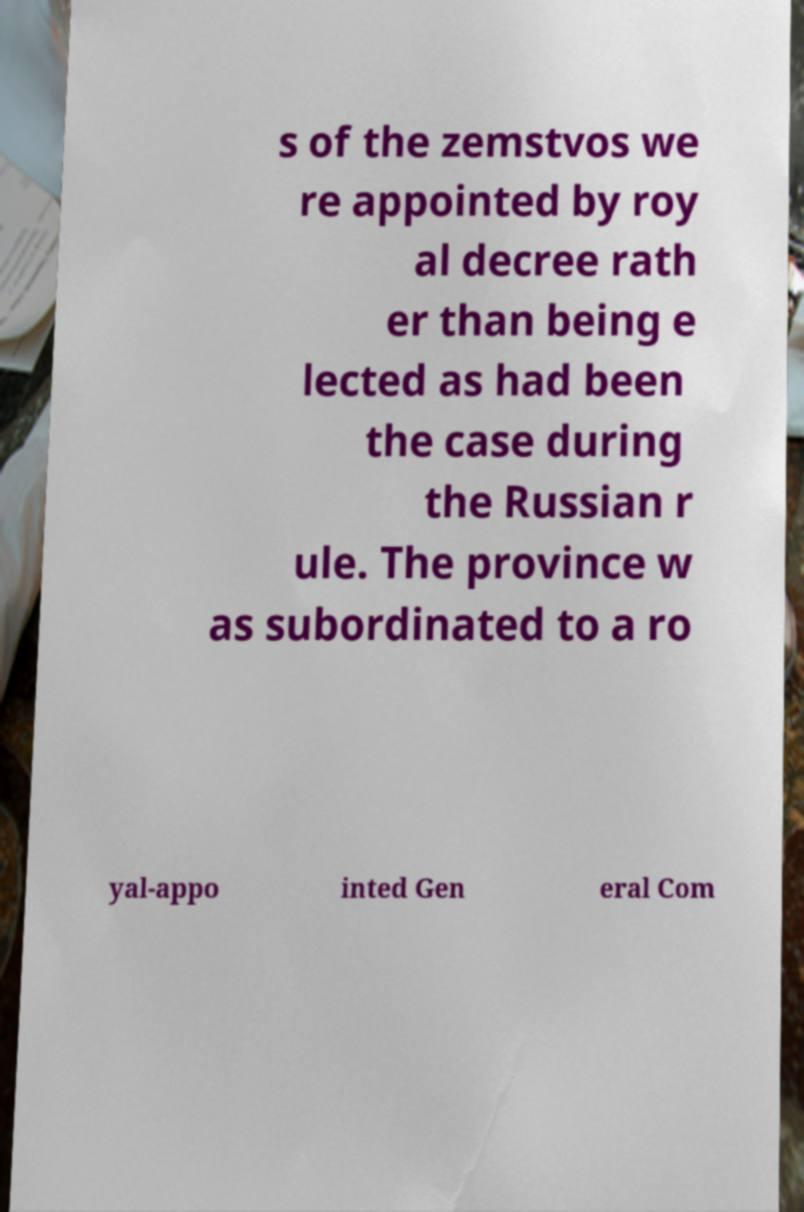What messages or text are displayed in this image? I need them in a readable, typed format. s of the zemstvos we re appointed by roy al decree rath er than being e lected as had been the case during the Russian r ule. The province w as subordinated to a ro yal-appo inted Gen eral Com 